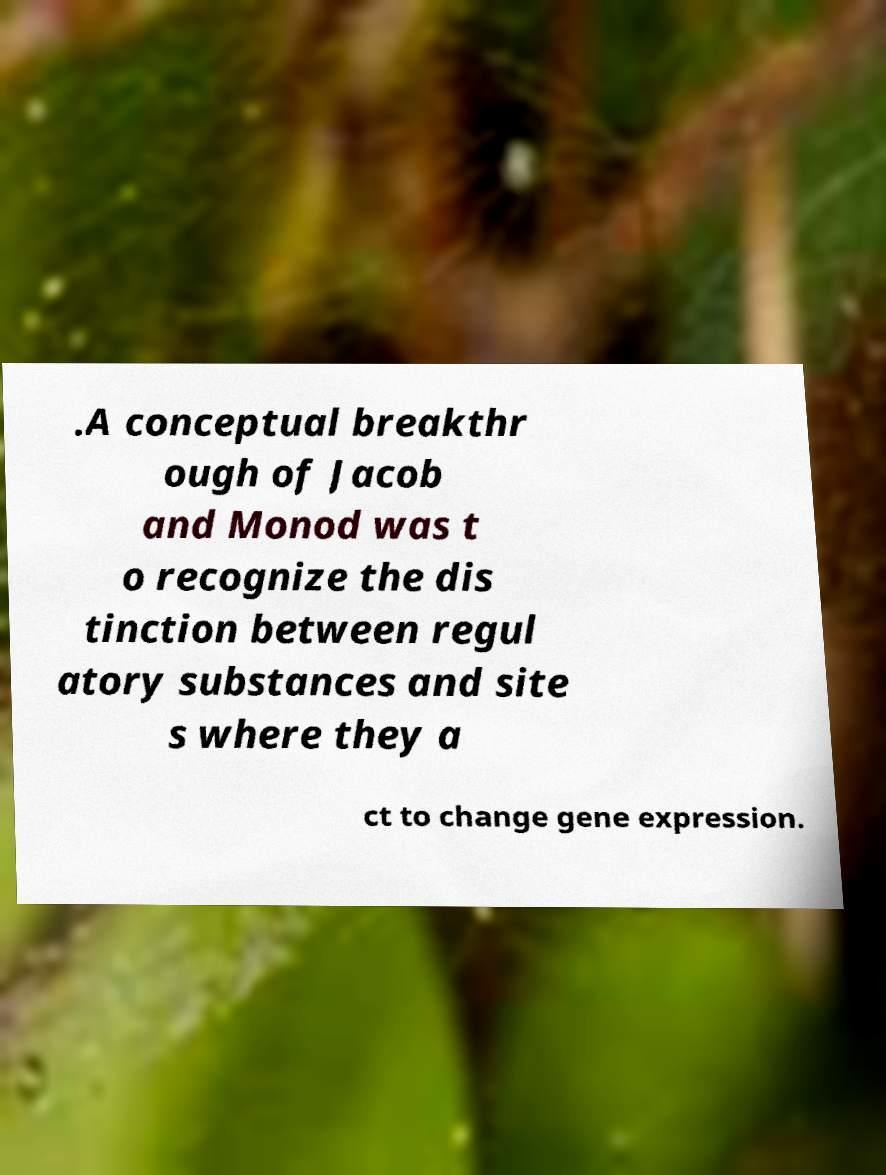Can you accurately transcribe the text from the provided image for me? .A conceptual breakthr ough of Jacob and Monod was t o recognize the dis tinction between regul atory substances and site s where they a ct to change gene expression. 